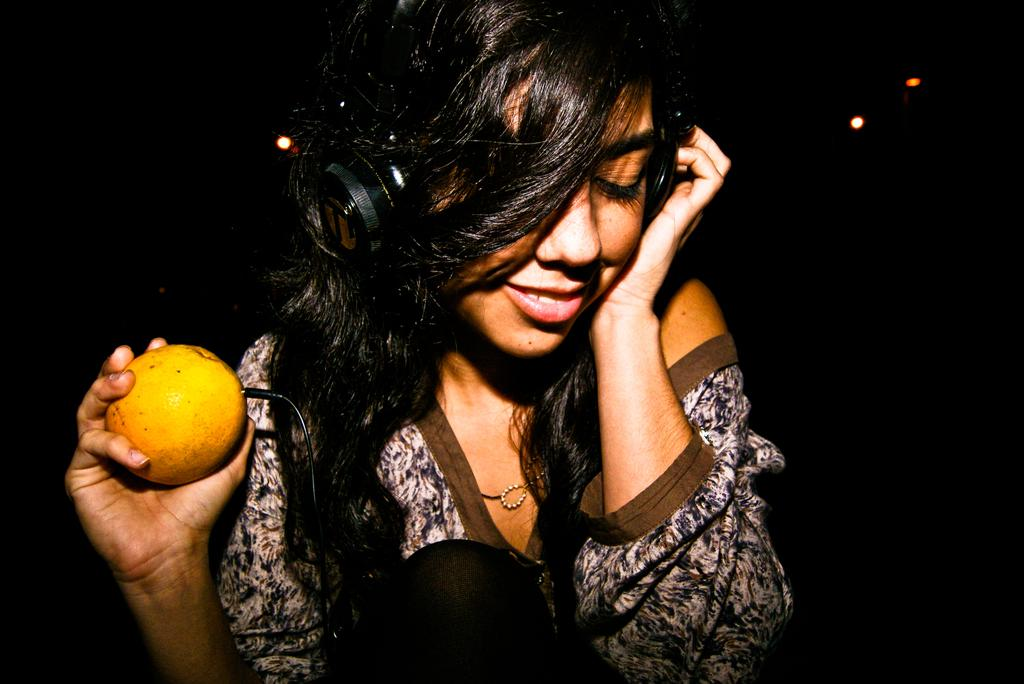What is the expression on the woman's face in the image? The woman is smiling in the image. What is the woman wearing on her head? The woman is wearing a wire headset in the image. How is the woman holding the headset? The woman is holding the headset with one hand in the image. What is the woman holding in her other hand? The woman is holding fruit in her other hand in the image. What can be seen in the image that might indicate a specific setting or activity? There are focusing lights in the image, which could suggest a recording or broadcasting environment. What is the color of the background in the image? The background of the image is dark. Can you tell me how many mines the woman is standing on in the image? There are no mines present in the image; it features a woman wearing a headset and holding fruit. What type of process is the woman participating in while holding the fruit? There is no specific process indicated in the image; the woman is simply holding fruit and wearing a headset. 